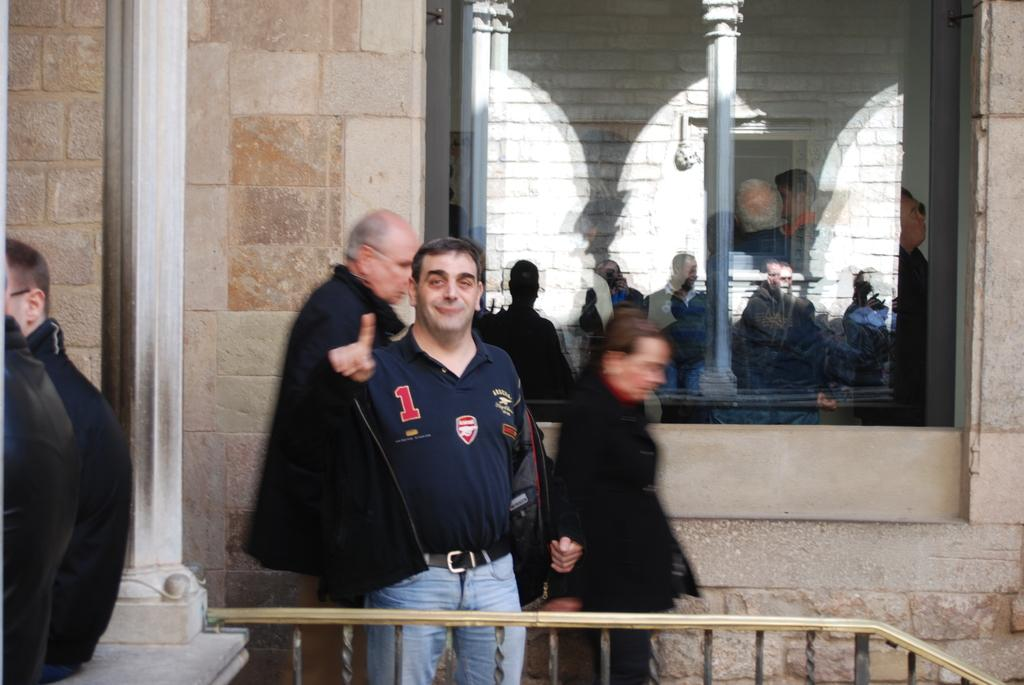What can be seen in the image? There are men standing in the image. What is the background of the image? There is a wall in the image. Is there any opening in the wall? Yes, there is a window in the image. How many nails can be seen holding the window in place in the image? There is no mention of nails in the image, and the window's attachment is not visible. 